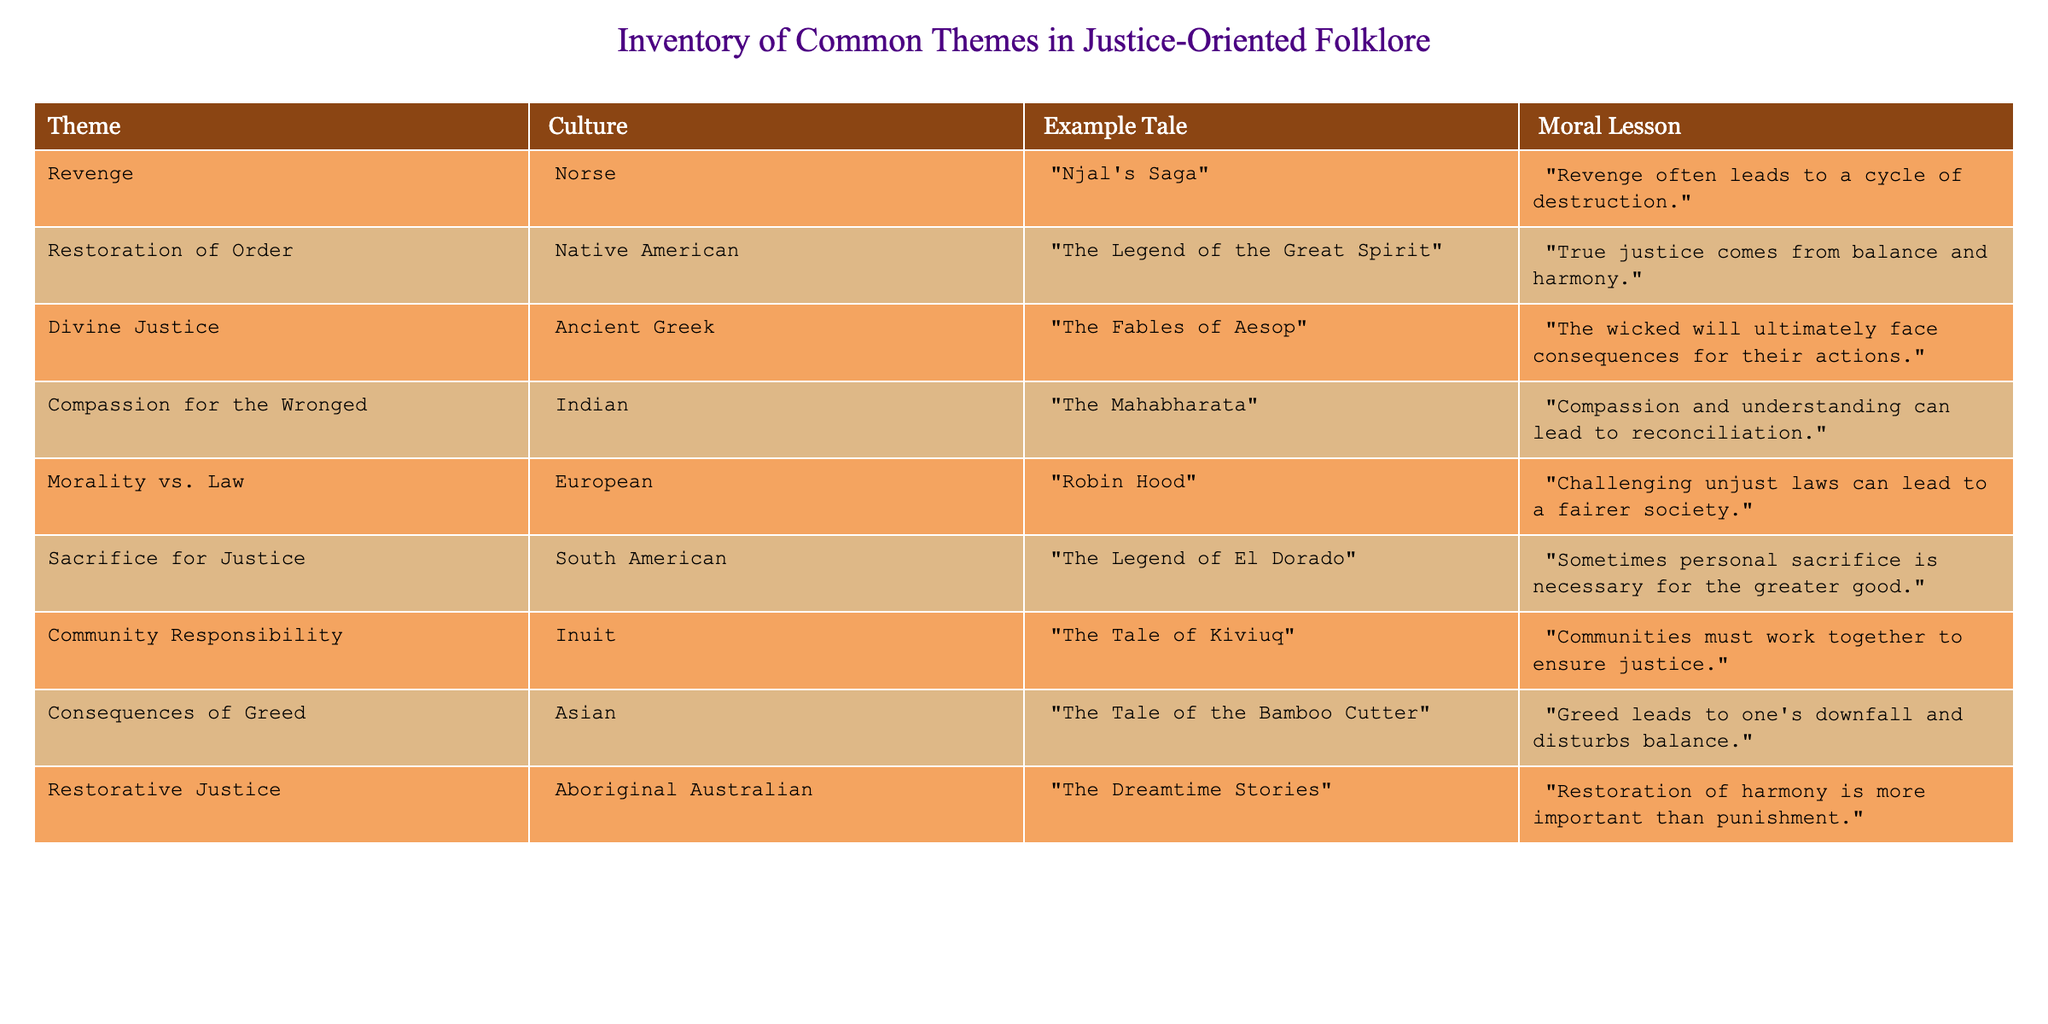What theme is associated with "The Mahabharata"? The table lists several themes alongside their respective tales. To find the theme associated with "The Mahabharata," I can look up this tale and see the theme mentioned in the same row, which is "Compassion for the Wronged."
Answer: Compassion for the Wronged Which culture is linked to the idea of "Restoration of Order"? Looking for the theme "Restoration of Order" in the table, I see it corresponds to Native American culture, mentioned in the same row.
Answer: Native American Is "The Fables of Aesop" an example of Divine Justice? By checking the table, I see that "The Fables of Aesop" is indeed listed under the theme of Divine Justice, confirming the presence of this association.
Answer: Yes What moral lesson is associated with the theme of sacrifice for justice? Referring to the row for "The Legend of El Dorado," I can see that the moral lesson associated with the theme of Sacrifice for Justice is "Sometimes personal sacrifice is necessary for the greater good."
Answer: Sometimes personal sacrifice is necessary for the greater good How many themes involve a sense of community responsibility? I scan the table for themes mentioning community, identifying the row for "The Tale of Kiviuq," which is linked to Community Responsibility. Since it is the only entry in this category, the count is one.
Answer: 1 Which cultural context has the moral lesson that greed leads to one's downfall? The table reveals that the theme of Consequences of Greed corresponds to the tale "The Tale of the Bamboo Cutter," which can be traced back to Asian culture.
Answer: Asian Are there more themes focused on justice involving individual sacrifice or collective responsibility? I find the themes "Sacrifice for Justice" and "Community Responsibility." Counting them, there is one theme (Sacrifice for Justice) about individual sacrifice and one theme (Community Responsibility) about collective responsibility, indicating they are equal.
Answer: Equal What is the commonality between "Robin Hood" and "Njal's Saga"? By examining the table, "Robin Hood" is associated with the theme of Morality vs. Law, while "Njal's Saga" corresponds to Revenge. Both tales explore complex moral dilemmas but under different themes.
Answer: Different themes on moral dilemmas 